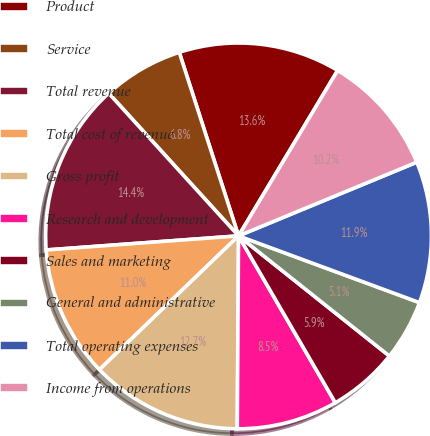Convert chart. <chart><loc_0><loc_0><loc_500><loc_500><pie_chart><fcel>Product<fcel>Service<fcel>Total revenue<fcel>Total cost of revenue<fcel>Gross profit<fcel>Research and development<fcel>Sales and marketing<fcel>General and administrative<fcel>Total operating expenses<fcel>Income from operations<nl><fcel>13.56%<fcel>6.78%<fcel>14.41%<fcel>11.02%<fcel>12.71%<fcel>8.47%<fcel>5.93%<fcel>5.08%<fcel>11.86%<fcel>10.17%<nl></chart> 